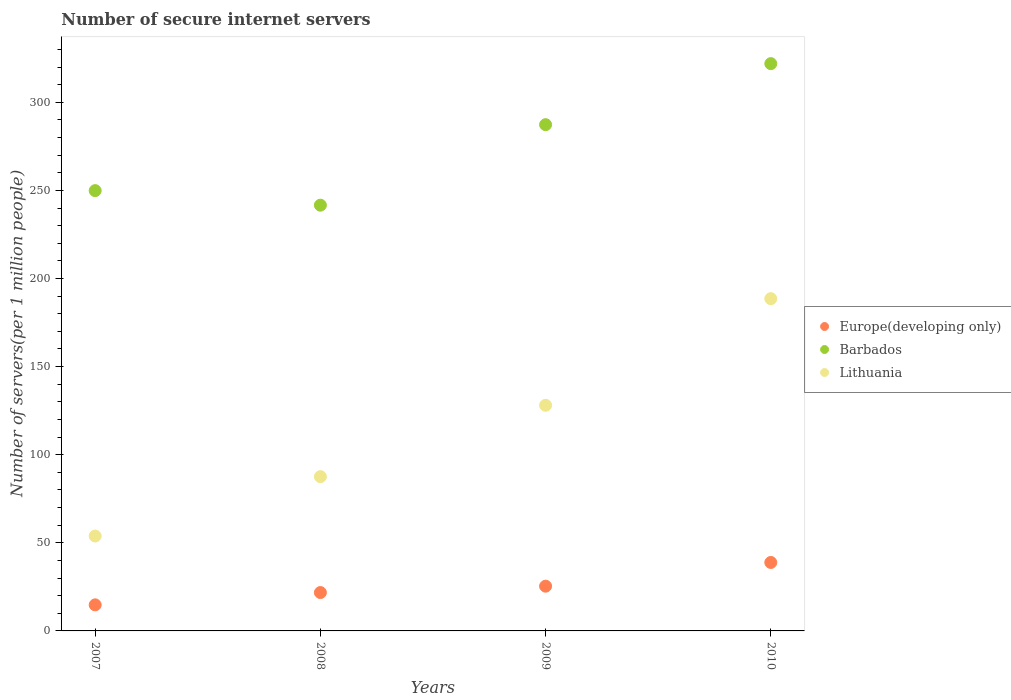How many different coloured dotlines are there?
Give a very brief answer. 3. What is the number of secure internet servers in Barbados in 2008?
Your answer should be compact. 241.6. Across all years, what is the maximum number of secure internet servers in Lithuania?
Keep it short and to the point. 188.55. Across all years, what is the minimum number of secure internet servers in Barbados?
Provide a short and direct response. 241.6. In which year was the number of secure internet servers in Europe(developing only) maximum?
Make the answer very short. 2010. What is the total number of secure internet servers in Barbados in the graph?
Your response must be concise. 1100.68. What is the difference between the number of secure internet servers in Barbados in 2007 and that in 2009?
Your answer should be compact. -37.43. What is the difference between the number of secure internet servers in Barbados in 2008 and the number of secure internet servers in Europe(developing only) in 2009?
Offer a terse response. 216.22. What is the average number of secure internet servers in Barbados per year?
Ensure brevity in your answer.  275.17. In the year 2008, what is the difference between the number of secure internet servers in Europe(developing only) and number of secure internet servers in Barbados?
Your answer should be very brief. -219.83. In how many years, is the number of secure internet servers in Barbados greater than 50?
Your answer should be very brief. 4. What is the ratio of the number of secure internet servers in Europe(developing only) in 2007 to that in 2008?
Your answer should be very brief. 0.68. Is the number of secure internet servers in Europe(developing only) in 2008 less than that in 2009?
Your answer should be compact. Yes. What is the difference between the highest and the second highest number of secure internet servers in Europe(developing only)?
Give a very brief answer. 13.46. What is the difference between the highest and the lowest number of secure internet servers in Barbados?
Give a very brief answer. 80.33. Is the sum of the number of secure internet servers in Barbados in 2009 and 2010 greater than the maximum number of secure internet servers in Europe(developing only) across all years?
Offer a terse response. Yes. Does the number of secure internet servers in Europe(developing only) monotonically increase over the years?
Provide a short and direct response. Yes. What is the difference between two consecutive major ticks on the Y-axis?
Make the answer very short. 50. Are the values on the major ticks of Y-axis written in scientific E-notation?
Your response must be concise. No. Does the graph contain grids?
Provide a short and direct response. No. Where does the legend appear in the graph?
Your answer should be very brief. Center right. How many legend labels are there?
Offer a very short reply. 3. What is the title of the graph?
Provide a short and direct response. Number of secure internet servers. What is the label or title of the X-axis?
Your answer should be very brief. Years. What is the label or title of the Y-axis?
Your response must be concise. Number of servers(per 1 million people). What is the Number of servers(per 1 million people) in Europe(developing only) in 2007?
Keep it short and to the point. 14.79. What is the Number of servers(per 1 million people) of Barbados in 2007?
Keep it short and to the point. 249.86. What is the Number of servers(per 1 million people) of Lithuania in 2007?
Provide a succinct answer. 53.85. What is the Number of servers(per 1 million people) in Europe(developing only) in 2008?
Ensure brevity in your answer.  21.78. What is the Number of servers(per 1 million people) in Barbados in 2008?
Provide a short and direct response. 241.6. What is the Number of servers(per 1 million people) of Lithuania in 2008?
Your answer should be compact. 87.55. What is the Number of servers(per 1 million people) of Europe(developing only) in 2009?
Offer a very short reply. 25.39. What is the Number of servers(per 1 million people) of Barbados in 2009?
Make the answer very short. 287.29. What is the Number of servers(per 1 million people) of Lithuania in 2009?
Provide a short and direct response. 128.05. What is the Number of servers(per 1 million people) of Europe(developing only) in 2010?
Keep it short and to the point. 38.85. What is the Number of servers(per 1 million people) in Barbados in 2010?
Your response must be concise. 321.93. What is the Number of servers(per 1 million people) in Lithuania in 2010?
Ensure brevity in your answer.  188.55. Across all years, what is the maximum Number of servers(per 1 million people) of Europe(developing only)?
Ensure brevity in your answer.  38.85. Across all years, what is the maximum Number of servers(per 1 million people) in Barbados?
Your answer should be compact. 321.93. Across all years, what is the maximum Number of servers(per 1 million people) in Lithuania?
Give a very brief answer. 188.55. Across all years, what is the minimum Number of servers(per 1 million people) in Europe(developing only)?
Give a very brief answer. 14.79. Across all years, what is the minimum Number of servers(per 1 million people) in Barbados?
Provide a short and direct response. 241.6. Across all years, what is the minimum Number of servers(per 1 million people) of Lithuania?
Your answer should be very brief. 53.85. What is the total Number of servers(per 1 million people) of Europe(developing only) in the graph?
Provide a succinct answer. 100.8. What is the total Number of servers(per 1 million people) in Barbados in the graph?
Your response must be concise. 1100.68. What is the total Number of servers(per 1 million people) of Lithuania in the graph?
Make the answer very short. 458. What is the difference between the Number of servers(per 1 million people) of Europe(developing only) in 2007 and that in 2008?
Ensure brevity in your answer.  -6.98. What is the difference between the Number of servers(per 1 million people) of Barbados in 2007 and that in 2008?
Ensure brevity in your answer.  8.26. What is the difference between the Number of servers(per 1 million people) in Lithuania in 2007 and that in 2008?
Keep it short and to the point. -33.7. What is the difference between the Number of servers(per 1 million people) in Europe(developing only) in 2007 and that in 2009?
Your response must be concise. -10.59. What is the difference between the Number of servers(per 1 million people) of Barbados in 2007 and that in 2009?
Ensure brevity in your answer.  -37.43. What is the difference between the Number of servers(per 1 million people) of Lithuania in 2007 and that in 2009?
Keep it short and to the point. -74.2. What is the difference between the Number of servers(per 1 million people) in Europe(developing only) in 2007 and that in 2010?
Offer a very short reply. -24.05. What is the difference between the Number of servers(per 1 million people) in Barbados in 2007 and that in 2010?
Provide a short and direct response. -72.07. What is the difference between the Number of servers(per 1 million people) of Lithuania in 2007 and that in 2010?
Make the answer very short. -134.7. What is the difference between the Number of servers(per 1 million people) in Europe(developing only) in 2008 and that in 2009?
Keep it short and to the point. -3.61. What is the difference between the Number of servers(per 1 million people) of Barbados in 2008 and that in 2009?
Offer a very short reply. -45.69. What is the difference between the Number of servers(per 1 million people) in Lithuania in 2008 and that in 2009?
Ensure brevity in your answer.  -40.5. What is the difference between the Number of servers(per 1 million people) in Europe(developing only) in 2008 and that in 2010?
Give a very brief answer. -17.07. What is the difference between the Number of servers(per 1 million people) in Barbados in 2008 and that in 2010?
Make the answer very short. -80.33. What is the difference between the Number of servers(per 1 million people) of Lithuania in 2008 and that in 2010?
Offer a very short reply. -101. What is the difference between the Number of servers(per 1 million people) in Europe(developing only) in 2009 and that in 2010?
Your answer should be compact. -13.46. What is the difference between the Number of servers(per 1 million people) in Barbados in 2009 and that in 2010?
Your answer should be very brief. -34.64. What is the difference between the Number of servers(per 1 million people) of Lithuania in 2009 and that in 2010?
Make the answer very short. -60.51. What is the difference between the Number of servers(per 1 million people) of Europe(developing only) in 2007 and the Number of servers(per 1 million people) of Barbados in 2008?
Give a very brief answer. -226.81. What is the difference between the Number of servers(per 1 million people) of Europe(developing only) in 2007 and the Number of servers(per 1 million people) of Lithuania in 2008?
Your answer should be very brief. -72.76. What is the difference between the Number of servers(per 1 million people) of Barbados in 2007 and the Number of servers(per 1 million people) of Lithuania in 2008?
Provide a short and direct response. 162.31. What is the difference between the Number of servers(per 1 million people) in Europe(developing only) in 2007 and the Number of servers(per 1 million people) in Barbados in 2009?
Make the answer very short. -272.5. What is the difference between the Number of servers(per 1 million people) in Europe(developing only) in 2007 and the Number of servers(per 1 million people) in Lithuania in 2009?
Offer a terse response. -113.25. What is the difference between the Number of servers(per 1 million people) of Barbados in 2007 and the Number of servers(per 1 million people) of Lithuania in 2009?
Keep it short and to the point. 121.81. What is the difference between the Number of servers(per 1 million people) of Europe(developing only) in 2007 and the Number of servers(per 1 million people) of Barbados in 2010?
Provide a short and direct response. -307.13. What is the difference between the Number of servers(per 1 million people) of Europe(developing only) in 2007 and the Number of servers(per 1 million people) of Lithuania in 2010?
Your response must be concise. -173.76. What is the difference between the Number of servers(per 1 million people) in Barbados in 2007 and the Number of servers(per 1 million people) in Lithuania in 2010?
Provide a succinct answer. 61.31. What is the difference between the Number of servers(per 1 million people) of Europe(developing only) in 2008 and the Number of servers(per 1 million people) of Barbados in 2009?
Offer a terse response. -265.51. What is the difference between the Number of servers(per 1 million people) of Europe(developing only) in 2008 and the Number of servers(per 1 million people) of Lithuania in 2009?
Offer a very short reply. -106.27. What is the difference between the Number of servers(per 1 million people) of Barbados in 2008 and the Number of servers(per 1 million people) of Lithuania in 2009?
Offer a terse response. 113.56. What is the difference between the Number of servers(per 1 million people) in Europe(developing only) in 2008 and the Number of servers(per 1 million people) in Barbados in 2010?
Your answer should be very brief. -300.15. What is the difference between the Number of servers(per 1 million people) of Europe(developing only) in 2008 and the Number of servers(per 1 million people) of Lithuania in 2010?
Provide a succinct answer. -166.78. What is the difference between the Number of servers(per 1 million people) of Barbados in 2008 and the Number of servers(per 1 million people) of Lithuania in 2010?
Provide a short and direct response. 53.05. What is the difference between the Number of servers(per 1 million people) of Europe(developing only) in 2009 and the Number of servers(per 1 million people) of Barbados in 2010?
Your answer should be very brief. -296.54. What is the difference between the Number of servers(per 1 million people) in Europe(developing only) in 2009 and the Number of servers(per 1 million people) in Lithuania in 2010?
Give a very brief answer. -163.17. What is the difference between the Number of servers(per 1 million people) of Barbados in 2009 and the Number of servers(per 1 million people) of Lithuania in 2010?
Provide a succinct answer. 98.74. What is the average Number of servers(per 1 million people) in Europe(developing only) per year?
Keep it short and to the point. 25.2. What is the average Number of servers(per 1 million people) of Barbados per year?
Provide a short and direct response. 275.17. What is the average Number of servers(per 1 million people) in Lithuania per year?
Keep it short and to the point. 114.5. In the year 2007, what is the difference between the Number of servers(per 1 million people) of Europe(developing only) and Number of servers(per 1 million people) of Barbados?
Offer a terse response. -235.07. In the year 2007, what is the difference between the Number of servers(per 1 million people) in Europe(developing only) and Number of servers(per 1 million people) in Lithuania?
Provide a succinct answer. -39.06. In the year 2007, what is the difference between the Number of servers(per 1 million people) of Barbados and Number of servers(per 1 million people) of Lithuania?
Your response must be concise. 196.01. In the year 2008, what is the difference between the Number of servers(per 1 million people) in Europe(developing only) and Number of servers(per 1 million people) in Barbados?
Provide a short and direct response. -219.83. In the year 2008, what is the difference between the Number of servers(per 1 million people) in Europe(developing only) and Number of servers(per 1 million people) in Lithuania?
Provide a short and direct response. -65.77. In the year 2008, what is the difference between the Number of servers(per 1 million people) of Barbados and Number of servers(per 1 million people) of Lithuania?
Your answer should be compact. 154.05. In the year 2009, what is the difference between the Number of servers(per 1 million people) of Europe(developing only) and Number of servers(per 1 million people) of Barbados?
Offer a very short reply. -261.9. In the year 2009, what is the difference between the Number of servers(per 1 million people) of Europe(developing only) and Number of servers(per 1 million people) of Lithuania?
Provide a short and direct response. -102.66. In the year 2009, what is the difference between the Number of servers(per 1 million people) in Barbados and Number of servers(per 1 million people) in Lithuania?
Make the answer very short. 159.24. In the year 2010, what is the difference between the Number of servers(per 1 million people) of Europe(developing only) and Number of servers(per 1 million people) of Barbados?
Offer a very short reply. -283.08. In the year 2010, what is the difference between the Number of servers(per 1 million people) in Europe(developing only) and Number of servers(per 1 million people) in Lithuania?
Offer a terse response. -149.71. In the year 2010, what is the difference between the Number of servers(per 1 million people) of Barbados and Number of servers(per 1 million people) of Lithuania?
Ensure brevity in your answer.  133.38. What is the ratio of the Number of servers(per 1 million people) of Europe(developing only) in 2007 to that in 2008?
Ensure brevity in your answer.  0.68. What is the ratio of the Number of servers(per 1 million people) of Barbados in 2007 to that in 2008?
Make the answer very short. 1.03. What is the ratio of the Number of servers(per 1 million people) in Lithuania in 2007 to that in 2008?
Offer a terse response. 0.62. What is the ratio of the Number of servers(per 1 million people) in Europe(developing only) in 2007 to that in 2009?
Give a very brief answer. 0.58. What is the ratio of the Number of servers(per 1 million people) of Barbados in 2007 to that in 2009?
Keep it short and to the point. 0.87. What is the ratio of the Number of servers(per 1 million people) in Lithuania in 2007 to that in 2009?
Offer a very short reply. 0.42. What is the ratio of the Number of servers(per 1 million people) in Europe(developing only) in 2007 to that in 2010?
Offer a very short reply. 0.38. What is the ratio of the Number of servers(per 1 million people) of Barbados in 2007 to that in 2010?
Ensure brevity in your answer.  0.78. What is the ratio of the Number of servers(per 1 million people) in Lithuania in 2007 to that in 2010?
Your response must be concise. 0.29. What is the ratio of the Number of servers(per 1 million people) of Europe(developing only) in 2008 to that in 2009?
Offer a terse response. 0.86. What is the ratio of the Number of servers(per 1 million people) in Barbados in 2008 to that in 2009?
Your response must be concise. 0.84. What is the ratio of the Number of servers(per 1 million people) in Lithuania in 2008 to that in 2009?
Your response must be concise. 0.68. What is the ratio of the Number of servers(per 1 million people) of Europe(developing only) in 2008 to that in 2010?
Your answer should be compact. 0.56. What is the ratio of the Number of servers(per 1 million people) of Barbados in 2008 to that in 2010?
Offer a terse response. 0.75. What is the ratio of the Number of servers(per 1 million people) of Lithuania in 2008 to that in 2010?
Your answer should be very brief. 0.46. What is the ratio of the Number of servers(per 1 million people) of Europe(developing only) in 2009 to that in 2010?
Make the answer very short. 0.65. What is the ratio of the Number of servers(per 1 million people) in Barbados in 2009 to that in 2010?
Your answer should be very brief. 0.89. What is the ratio of the Number of servers(per 1 million people) in Lithuania in 2009 to that in 2010?
Your response must be concise. 0.68. What is the difference between the highest and the second highest Number of servers(per 1 million people) of Europe(developing only)?
Your response must be concise. 13.46. What is the difference between the highest and the second highest Number of servers(per 1 million people) of Barbados?
Offer a terse response. 34.64. What is the difference between the highest and the second highest Number of servers(per 1 million people) of Lithuania?
Your answer should be very brief. 60.51. What is the difference between the highest and the lowest Number of servers(per 1 million people) in Europe(developing only)?
Offer a terse response. 24.05. What is the difference between the highest and the lowest Number of servers(per 1 million people) in Barbados?
Provide a succinct answer. 80.33. What is the difference between the highest and the lowest Number of servers(per 1 million people) of Lithuania?
Ensure brevity in your answer.  134.7. 